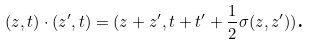<formula> <loc_0><loc_0><loc_500><loc_500>( z , t ) \cdot ( z ^ { \prime } , t ) = ( z + z ^ { \prime } , t + t ^ { \prime } + \frac { 1 } { 2 } \sigma ( z , z ^ { \prime } ) ) \text {.}</formula> 